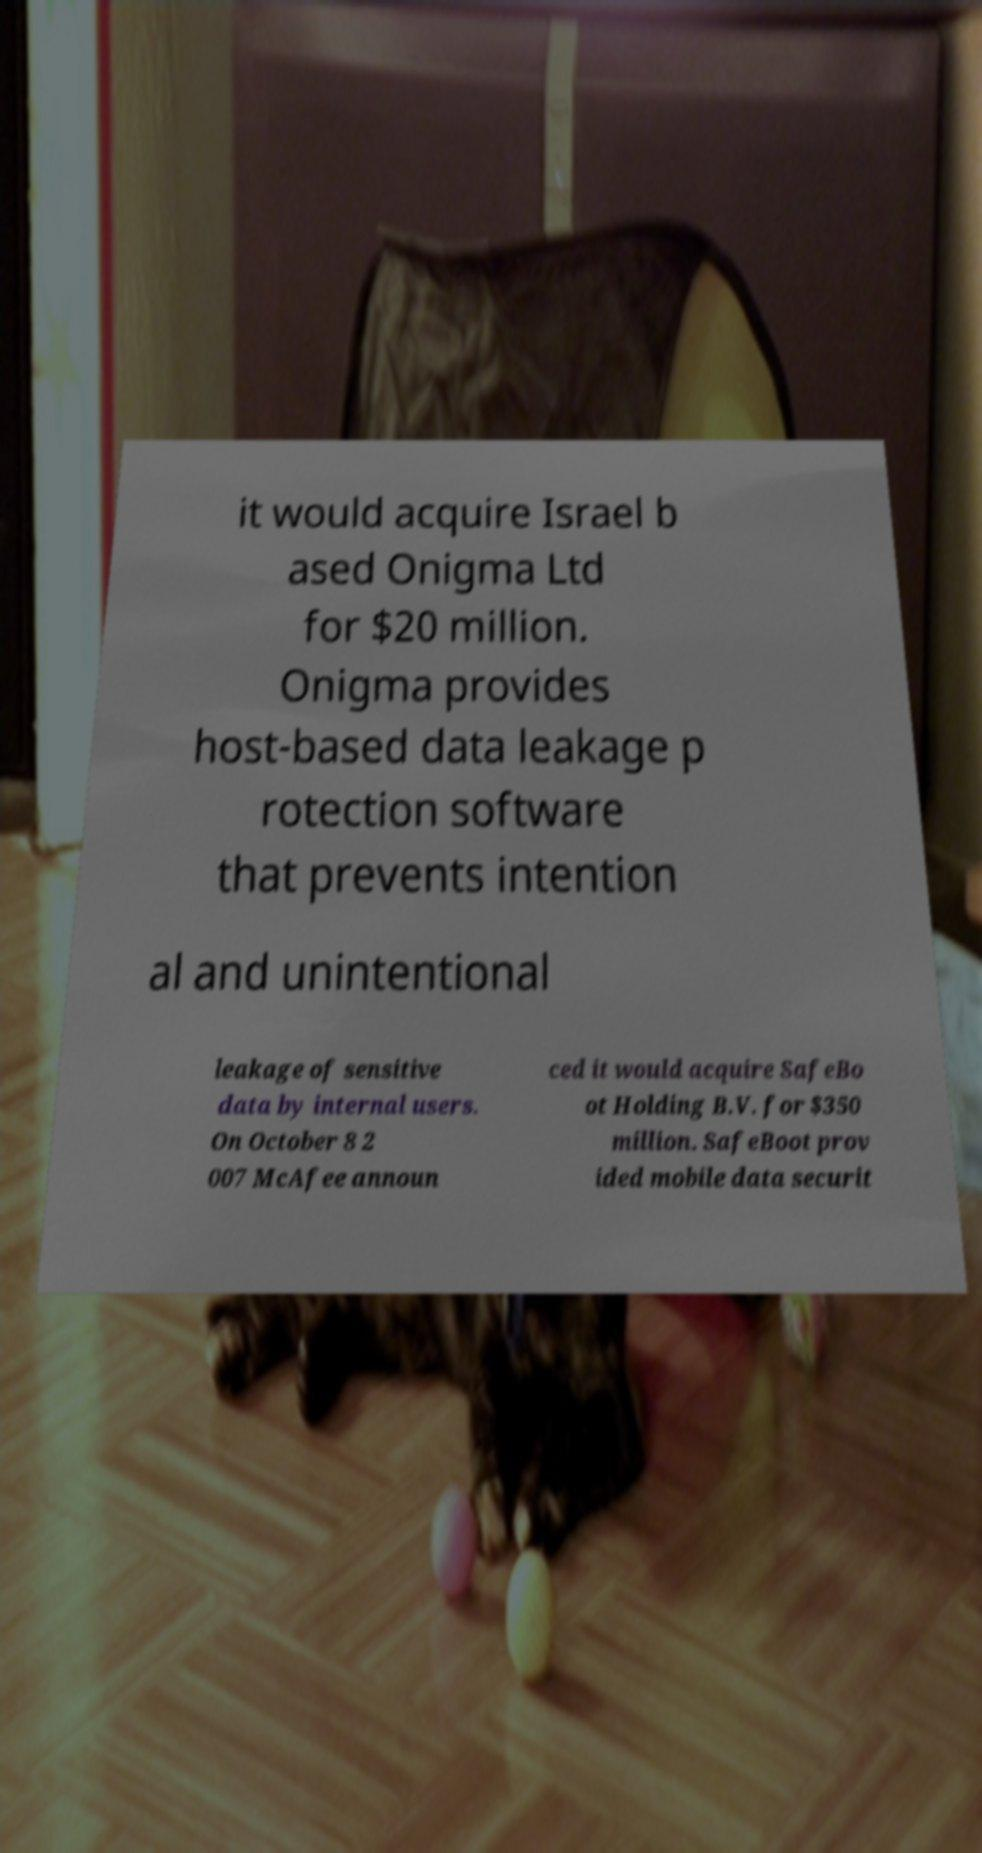Could you extract and type out the text from this image? it would acquire Israel b ased Onigma Ltd for $20 million. Onigma provides host-based data leakage p rotection software that prevents intention al and unintentional leakage of sensitive data by internal users. On October 8 2 007 McAfee announ ced it would acquire SafeBo ot Holding B.V. for $350 million. SafeBoot prov ided mobile data securit 